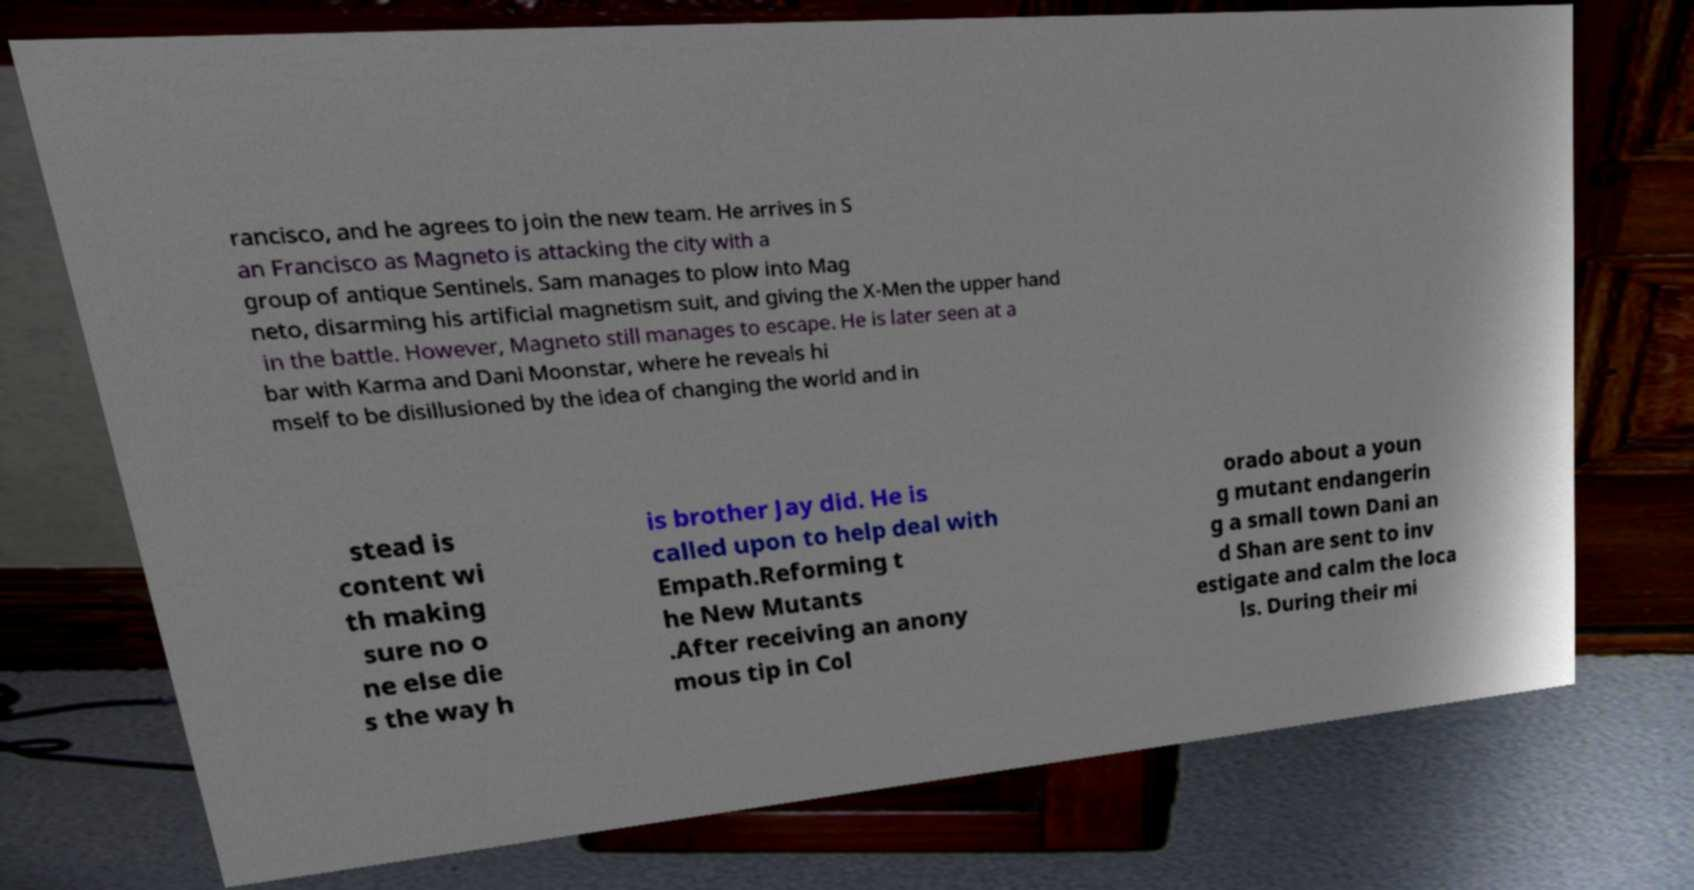Please read and relay the text visible in this image. What does it say? rancisco, and he agrees to join the new team. He arrives in S an Francisco as Magneto is attacking the city with a group of antique Sentinels. Sam manages to plow into Mag neto, disarming his artificial magnetism suit, and giving the X-Men the upper hand in the battle. However, Magneto still manages to escape. He is later seen at a bar with Karma and Dani Moonstar, where he reveals hi mself to be disillusioned by the idea of changing the world and in stead is content wi th making sure no o ne else die s the way h is brother Jay did. He is called upon to help deal with Empath.Reforming t he New Mutants .After receiving an anony mous tip in Col orado about a youn g mutant endangerin g a small town Dani an d Shan are sent to inv estigate and calm the loca ls. During their mi 